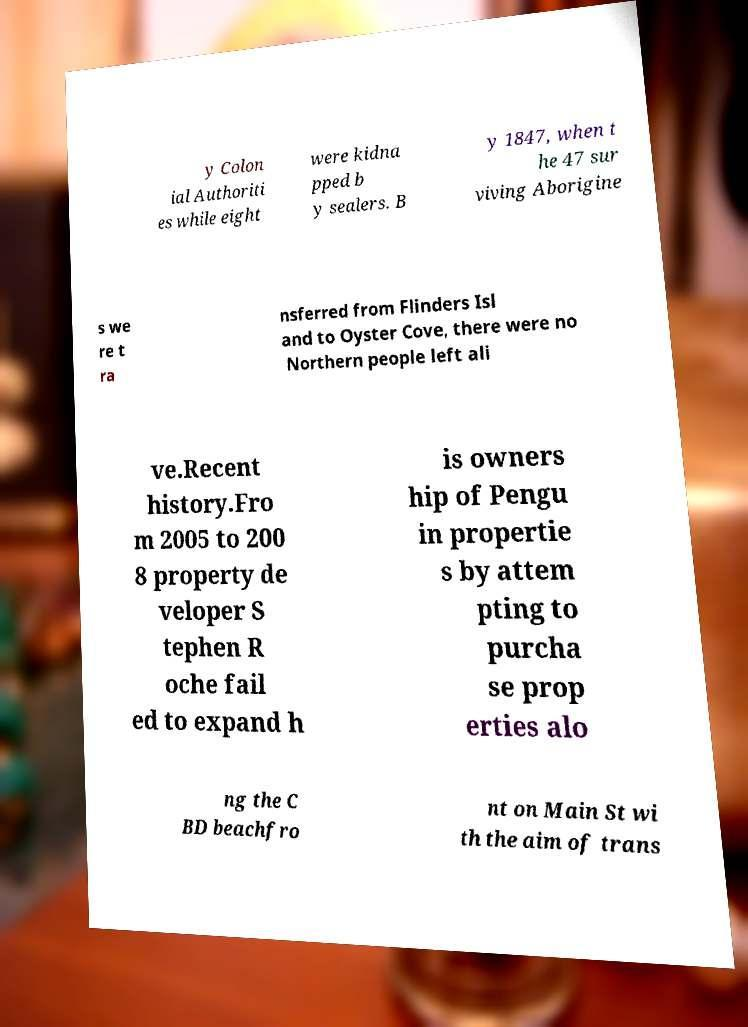There's text embedded in this image that I need extracted. Can you transcribe it verbatim? y Colon ial Authoriti es while eight were kidna pped b y sealers. B y 1847, when t he 47 sur viving Aborigine s we re t ra nsferred from Flinders Isl and to Oyster Cove, there were no Northern people left ali ve.Recent history.Fro m 2005 to 200 8 property de veloper S tephen R oche fail ed to expand h is owners hip of Pengu in propertie s by attem pting to purcha se prop erties alo ng the C BD beachfro nt on Main St wi th the aim of trans 